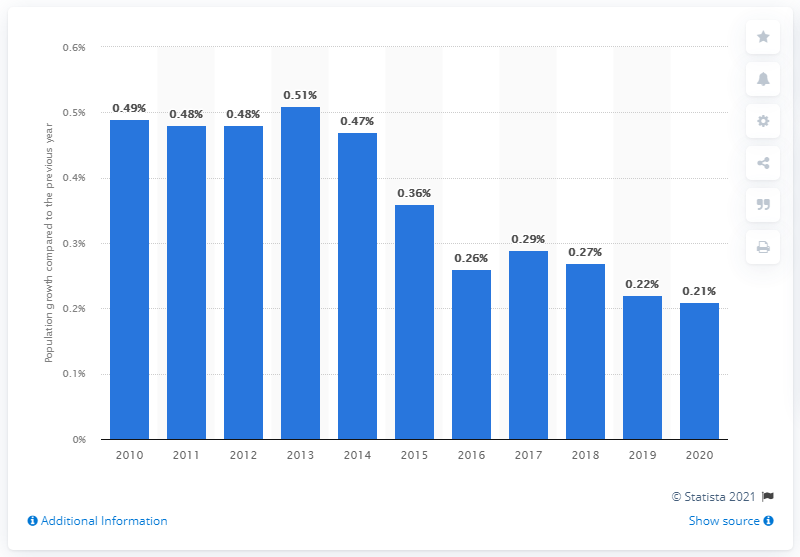Indicate a few pertinent items in this graphic. In 2020, the population growth in France was 0.21%. 